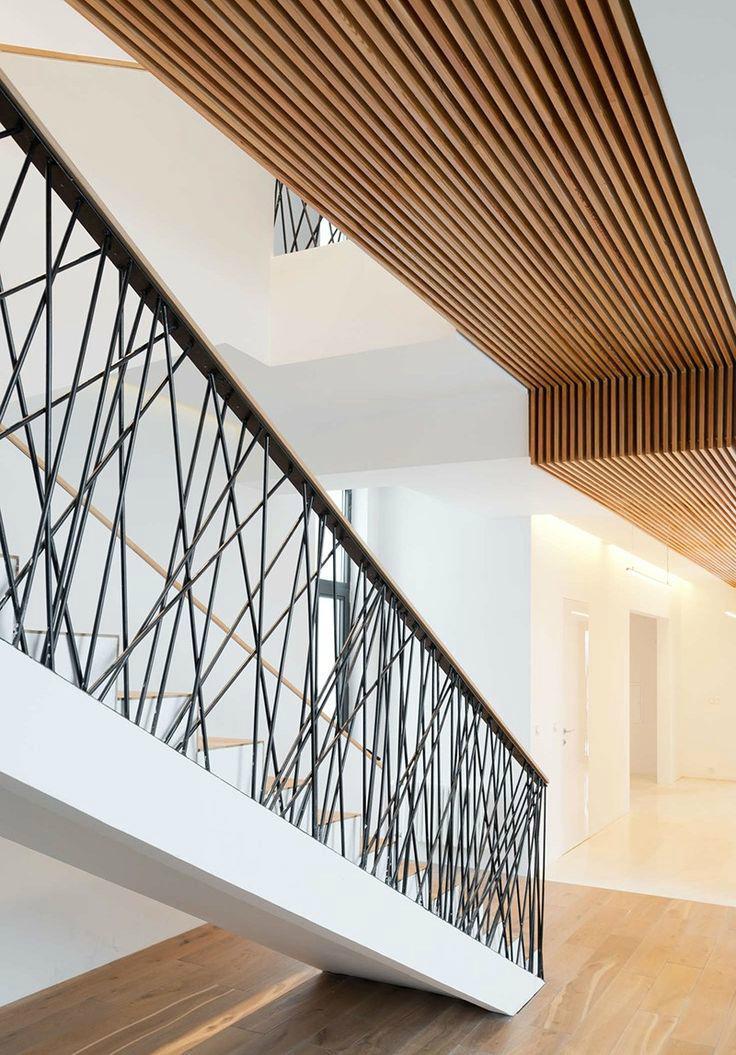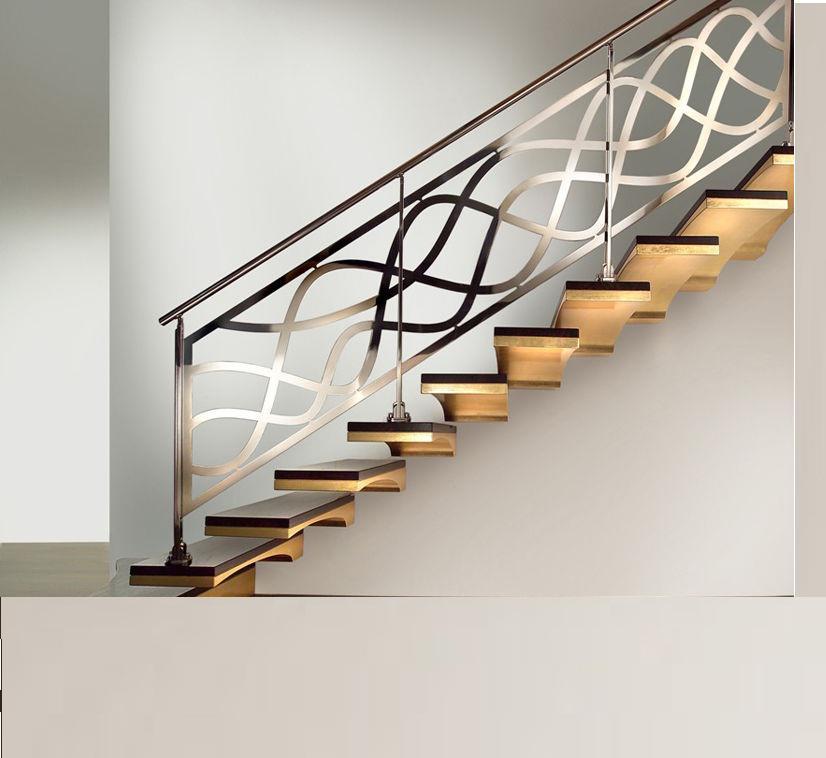The first image is the image on the left, the second image is the image on the right. Analyze the images presented: Is the assertion "At least one staircase that combines brown wood steps with white paint starts from the lower left angling rightward, then turns sharply back to the left." valid? Answer yes or no. No. 